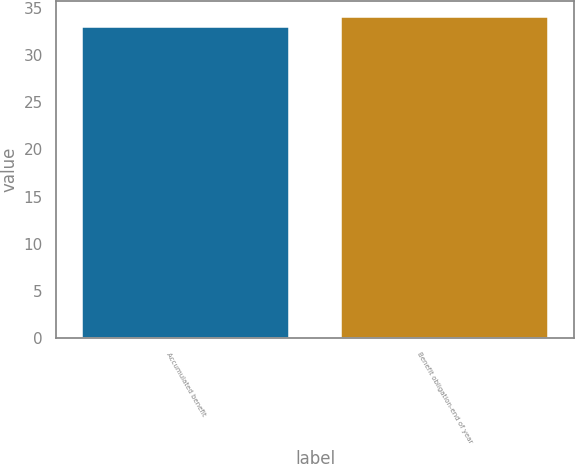Convert chart. <chart><loc_0><loc_0><loc_500><loc_500><bar_chart><fcel>Accumulated benefit<fcel>Benefit obligation-end of year<nl><fcel>33<fcel>34<nl></chart> 